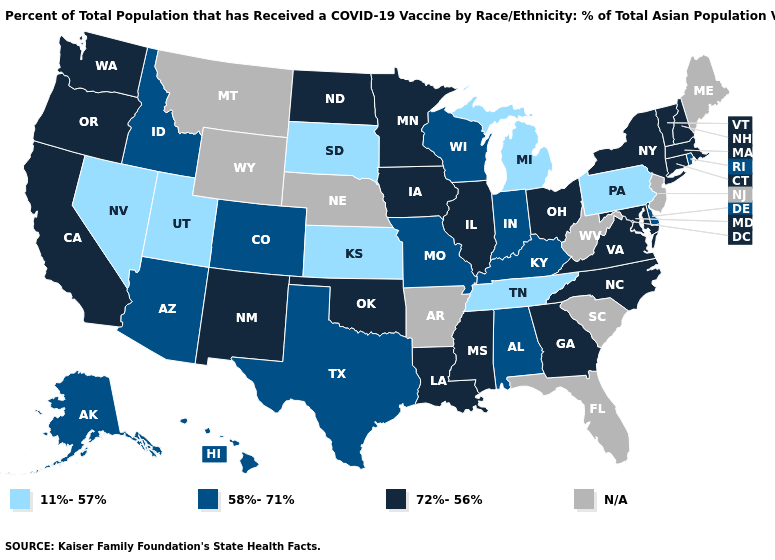Does the first symbol in the legend represent the smallest category?
Concise answer only. Yes. Which states hav the highest value in the MidWest?
Keep it brief. Illinois, Iowa, Minnesota, North Dakota, Ohio. What is the value of Utah?
Write a very short answer. 11%-57%. Among the states that border Massachusetts , which have the highest value?
Concise answer only. Connecticut, New Hampshire, New York, Vermont. Does Ohio have the highest value in the USA?
Keep it brief. Yes. What is the value of Rhode Island?
Write a very short answer. 58%-71%. Among the states that border New York , which have the highest value?
Answer briefly. Connecticut, Massachusetts, Vermont. Does Ohio have the highest value in the MidWest?
Short answer required. Yes. Name the states that have a value in the range 11%-57%?
Keep it brief. Kansas, Michigan, Nevada, Pennsylvania, South Dakota, Tennessee, Utah. Name the states that have a value in the range N/A?
Be succinct. Arkansas, Florida, Maine, Montana, Nebraska, New Jersey, South Carolina, West Virginia, Wyoming. Does Utah have the lowest value in the West?
Keep it brief. Yes. What is the value of Utah?
Write a very short answer. 11%-57%. Does the first symbol in the legend represent the smallest category?
Short answer required. Yes. What is the highest value in the USA?
Keep it brief. 72%-56%. 